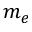Convert formula to latex. <formula><loc_0><loc_0><loc_500><loc_500>m _ { e }</formula> 